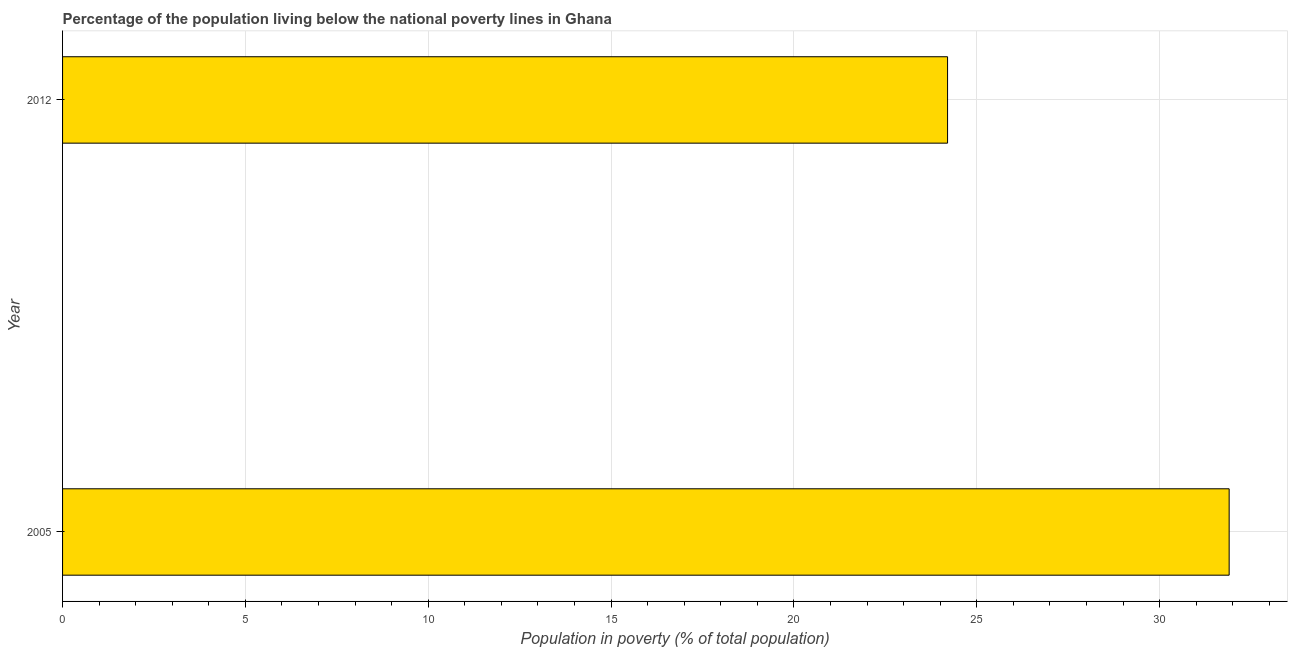What is the title of the graph?
Keep it short and to the point. Percentage of the population living below the national poverty lines in Ghana. What is the label or title of the X-axis?
Offer a terse response. Population in poverty (% of total population). What is the percentage of population living below poverty line in 2005?
Your answer should be very brief. 31.9. Across all years, what is the maximum percentage of population living below poverty line?
Offer a terse response. 31.9. Across all years, what is the minimum percentage of population living below poverty line?
Provide a succinct answer. 24.2. What is the sum of the percentage of population living below poverty line?
Provide a succinct answer. 56.1. What is the average percentage of population living below poverty line per year?
Ensure brevity in your answer.  28.05. What is the median percentage of population living below poverty line?
Your response must be concise. 28.05. What is the ratio of the percentage of population living below poverty line in 2005 to that in 2012?
Offer a very short reply. 1.32. How many years are there in the graph?
Offer a terse response. 2. Are the values on the major ticks of X-axis written in scientific E-notation?
Provide a short and direct response. No. What is the Population in poverty (% of total population) in 2005?
Provide a short and direct response. 31.9. What is the Population in poverty (% of total population) of 2012?
Ensure brevity in your answer.  24.2. What is the difference between the Population in poverty (% of total population) in 2005 and 2012?
Provide a short and direct response. 7.7. What is the ratio of the Population in poverty (% of total population) in 2005 to that in 2012?
Offer a terse response. 1.32. 